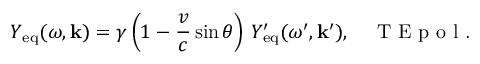Convert formula to latex. <formula><loc_0><loc_0><loc_500><loc_500>Y _ { e q } ( \omega , k ) = \gamma \left ( 1 - \frac { v } { c } \sin \theta \right ) \, Y _ { e q } ^ { \prime } ( \omega ^ { \prime } , k ^ { \prime } ) , \quad T E p o l .</formula> 